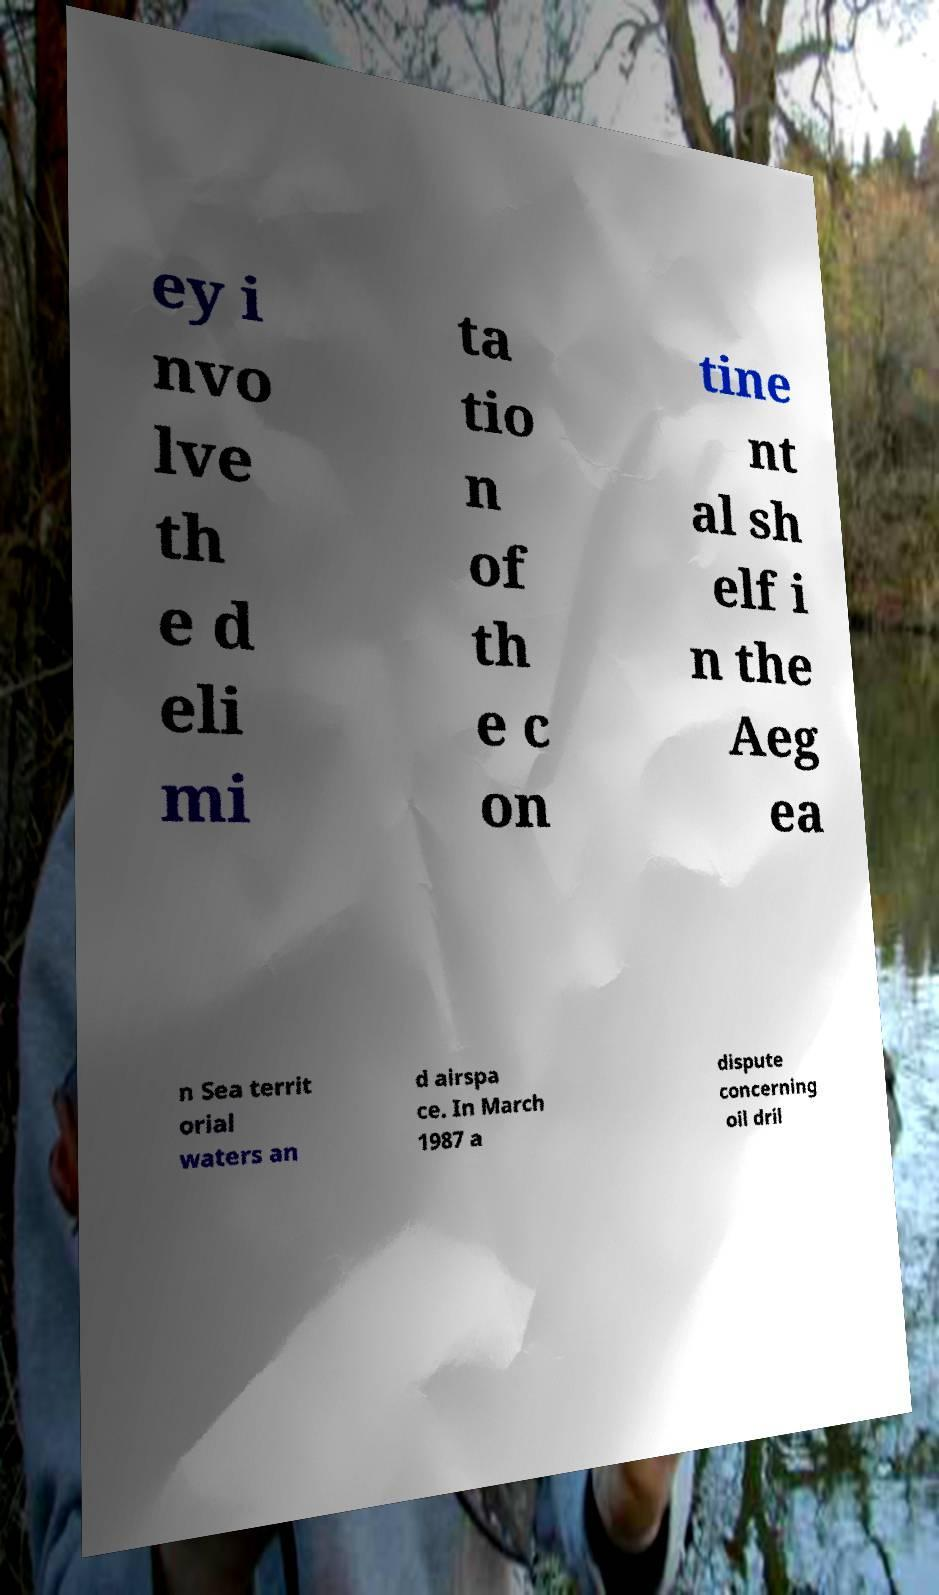Please identify and transcribe the text found in this image. ey i nvo lve th e d eli mi ta tio n of th e c on tine nt al sh elf i n the Aeg ea n Sea territ orial waters an d airspa ce. In March 1987 a dispute concerning oil dril 